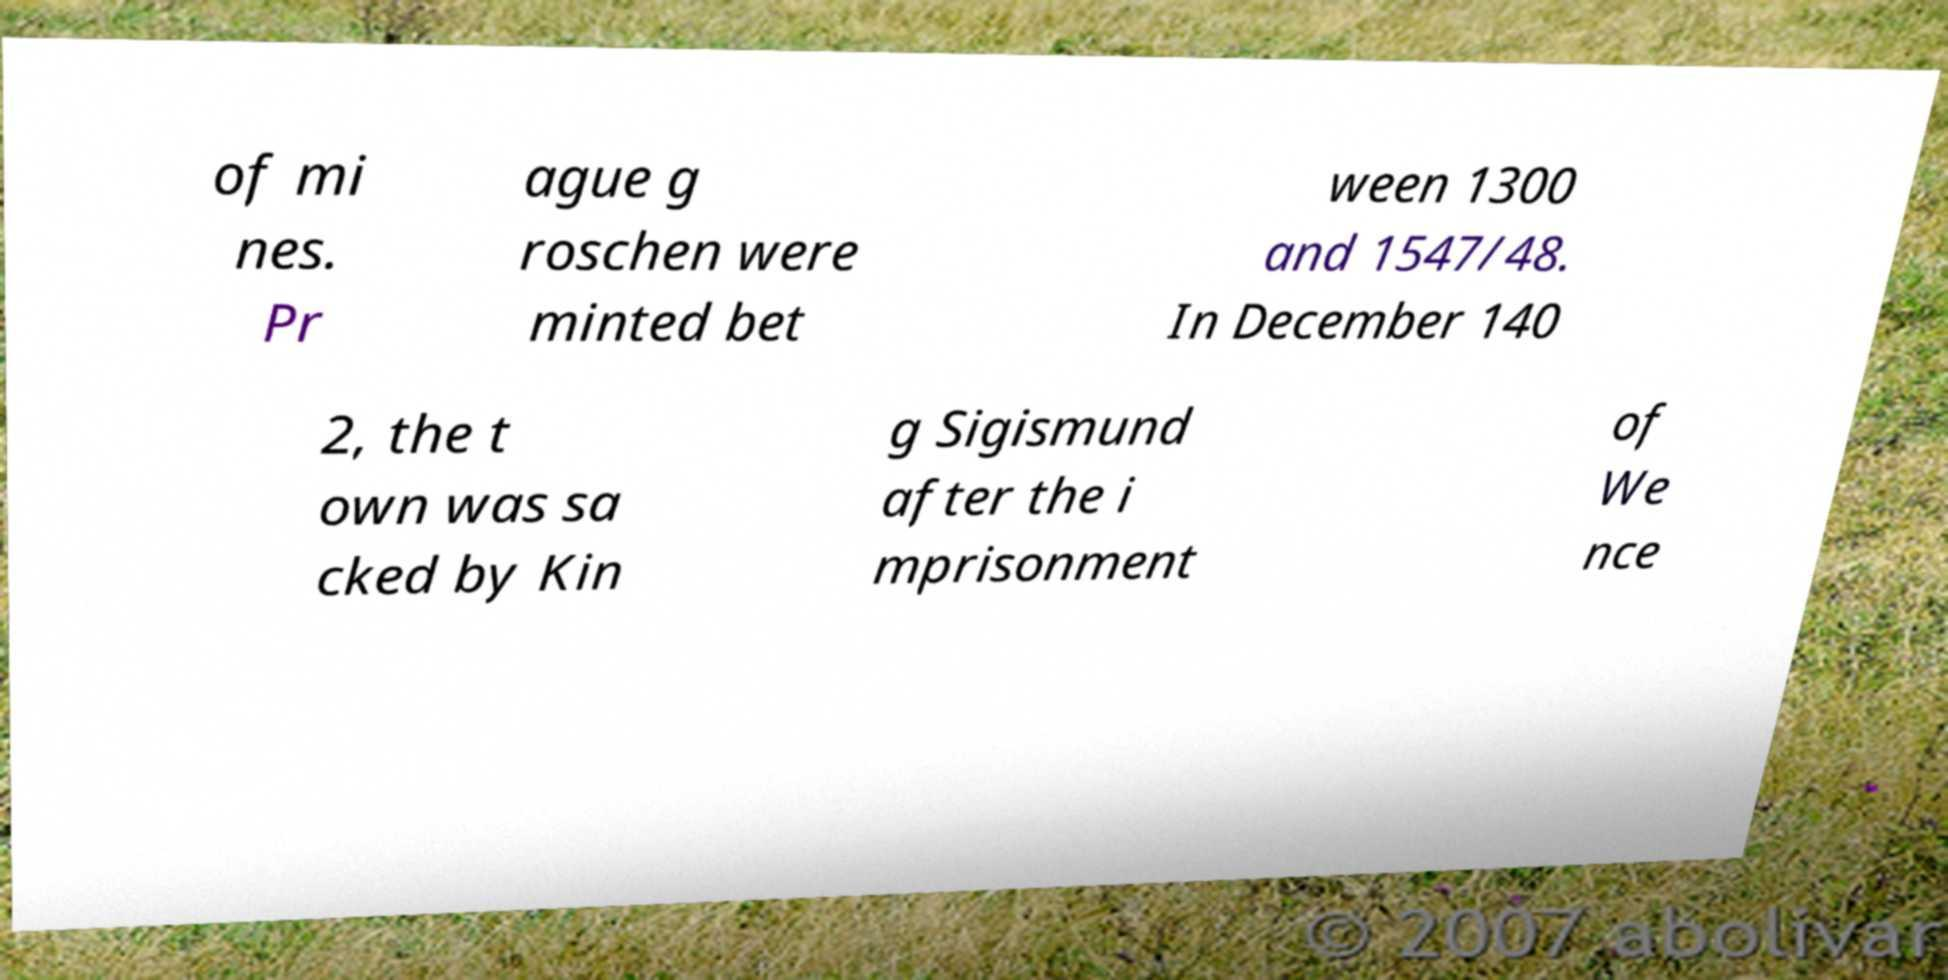Please read and relay the text visible in this image. What does it say? of mi nes. Pr ague g roschen were minted bet ween 1300 and 1547/48. In December 140 2, the t own was sa cked by Kin g Sigismund after the i mprisonment of We nce 